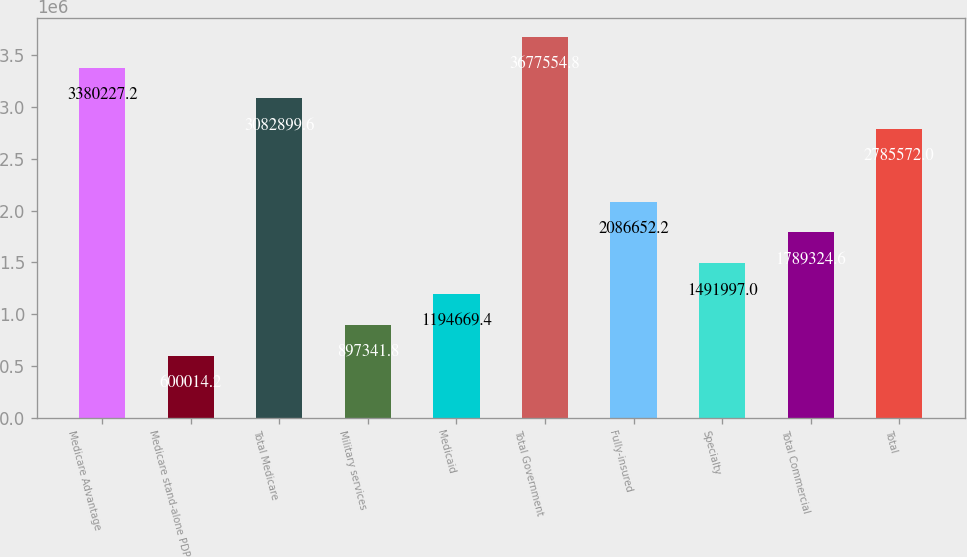Convert chart. <chart><loc_0><loc_0><loc_500><loc_500><bar_chart><fcel>Medicare Advantage<fcel>Medicare stand-alone PDP<fcel>Total Medicare<fcel>Military services<fcel>Medicaid<fcel>Total Government<fcel>Fully-insured<fcel>Specialty<fcel>Total Commercial<fcel>Total<nl><fcel>3.38023e+06<fcel>600014<fcel>3.0829e+06<fcel>897342<fcel>1.19467e+06<fcel>3.67755e+06<fcel>2.08665e+06<fcel>1.492e+06<fcel>1.78932e+06<fcel>2.78557e+06<nl></chart> 